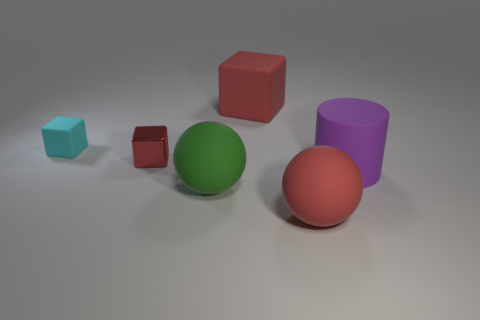Subtract all yellow spheres. Subtract all purple cylinders. How many spheres are left? 2 Subtract all cyan balls. How many brown cubes are left? 0 Add 3 greens. How many things exist? 0 Subtract all big red things. Subtract all small red metallic cubes. How many objects are left? 3 Add 3 tiny red shiny things. How many tiny red shiny things are left? 4 Add 3 big purple rubber cylinders. How many big purple rubber cylinders exist? 4 Add 3 large matte cubes. How many objects exist? 9 Subtract all red cubes. How many cubes are left? 1 Subtract all big cubes. How many cubes are left? 2 Subtract 0 cyan cylinders. How many objects are left? 6 